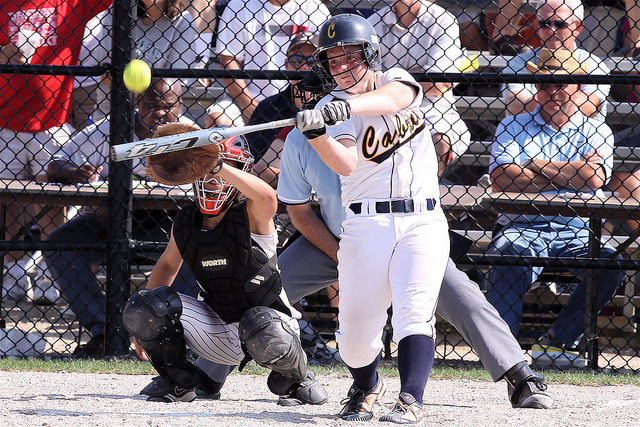Is there any indication of the time of day the game is taking place? While the image does not provide direct evidence for the time of day like the position of shadows or the sun, the overall brightness suggests that it is likely daytime. However, pinpointing the exact time is not possible without additional context. 